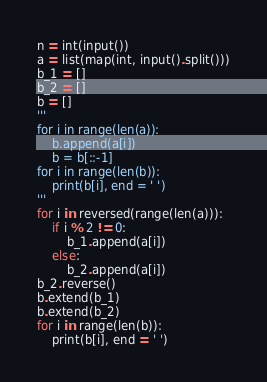Convert code to text. <code><loc_0><loc_0><loc_500><loc_500><_Python_>n = int(input())
a = list(map(int, input().split()))
b_1 = []
b_2 = []
b = []
'''
for i in range(len(a)):
	b.append(a[i])
	b = b[::-1]
for i in range(len(b)):
	print(b[i], end = ' ')
'''
for i in reversed(range(len(a))):
	if i % 2 != 0:
		b_1.append(a[i])
	else:
		b_2.append(a[i])
b_2.reverse()
b.extend(b_1)
b.extend(b_2)
for i in range(len(b)):
	print(b[i], end = ' ')</code> 